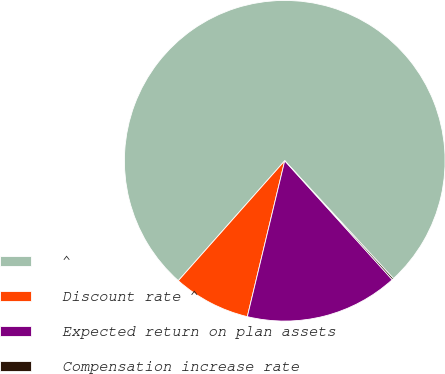<chart> <loc_0><loc_0><loc_500><loc_500><pie_chart><fcel>^<fcel>Discount rate ^<fcel>Expected return on plan assets<fcel>Compensation increase rate<nl><fcel>76.59%<fcel>7.8%<fcel>15.45%<fcel>0.16%<nl></chart> 